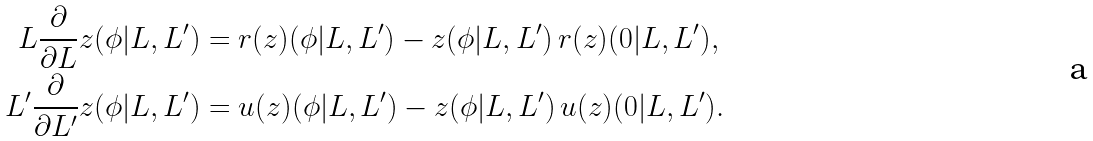<formula> <loc_0><loc_0><loc_500><loc_500>L \frac { \partial } { \partial L } z ( \phi | L , L ^ { \prime } ) & = r ( z ) ( \phi | L , L ^ { \prime } ) - z ( \phi | L , L ^ { \prime } ) \, r ( z ) ( 0 | L , L ^ { \prime } ) , \\ L ^ { \prime } \frac { \partial } { \partial L ^ { \prime } } z ( \phi | L , L ^ { \prime } ) & = u ( z ) ( \phi | L , L ^ { \prime } ) - z ( \phi | L , L ^ { \prime } ) \, u ( z ) ( 0 | L , L ^ { \prime } ) .</formula> 